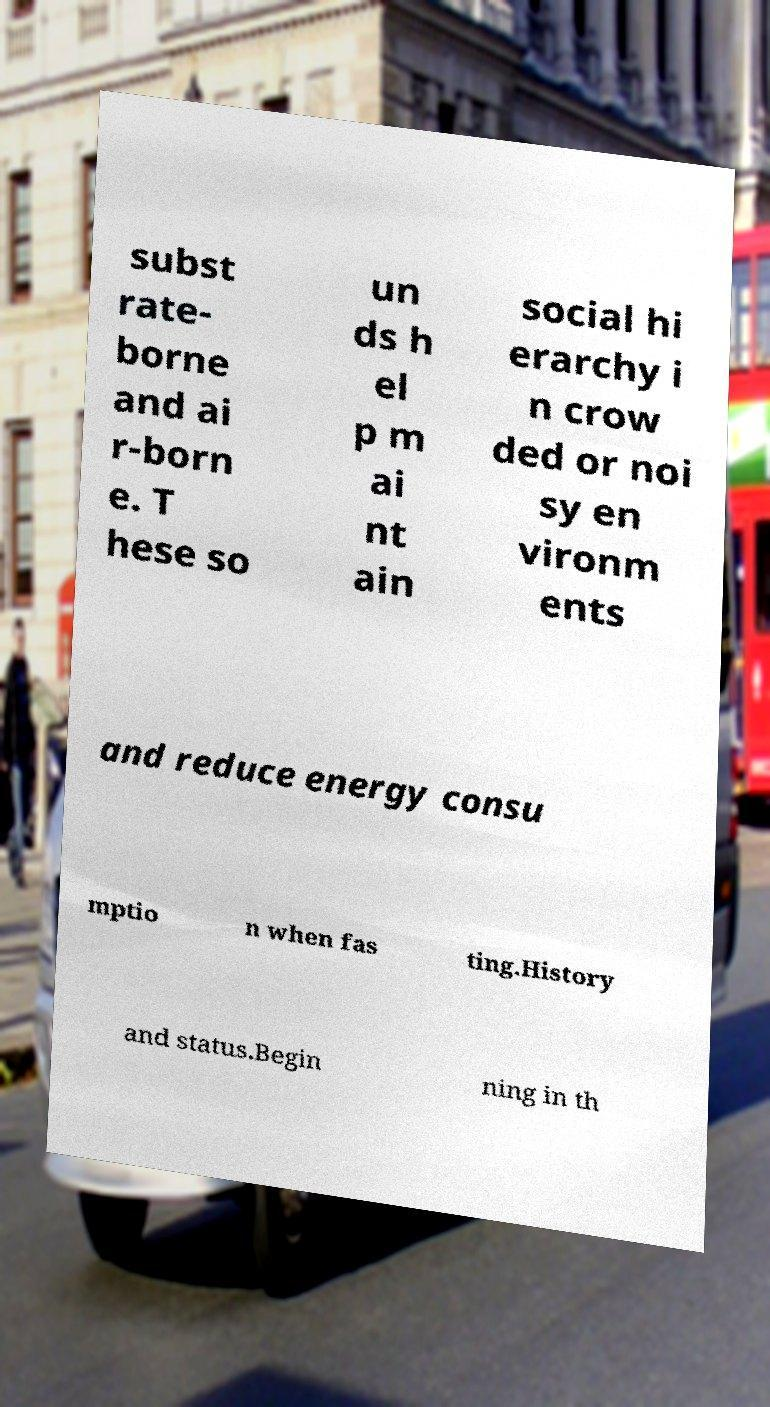Could you assist in decoding the text presented in this image and type it out clearly? subst rate- borne and ai r-born e. T hese so un ds h el p m ai nt ain social hi erarchy i n crow ded or noi sy en vironm ents and reduce energy consu mptio n when fas ting.History and status.Begin ning in th 